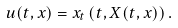Convert formula to latex. <formula><loc_0><loc_0><loc_500><loc_500>u ( t , x ) = x _ { t } \left ( t , X ( t , x ) \right ) .</formula> 